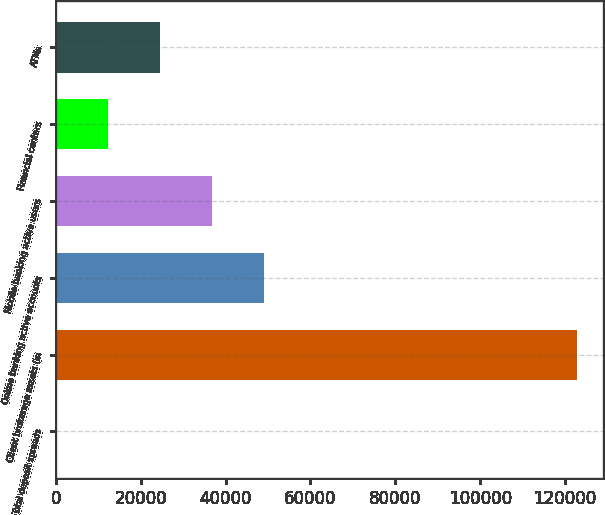Convert chart to OTSL. <chart><loc_0><loc_0><loc_500><loc_500><bar_chart><fcel>Total deposit spreads<fcel>Client brokerage assets (in<fcel>Online banking active accounts<fcel>Mobile banking active users<fcel>Financial centers<fcel>ATMs<nl><fcel>1.62<fcel>122721<fcel>49089.4<fcel>36817.4<fcel>12273.6<fcel>24545.5<nl></chart> 